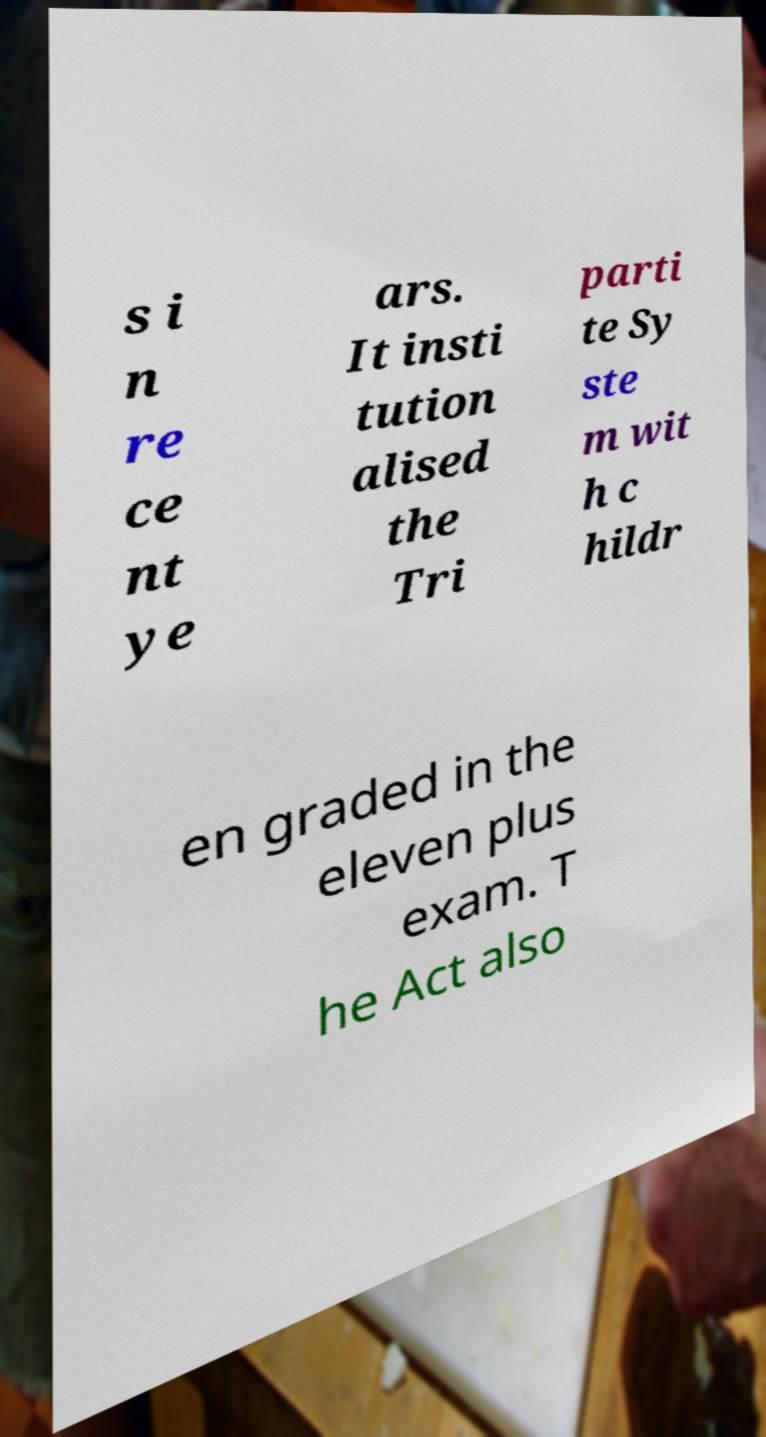Can you accurately transcribe the text from the provided image for me? s i n re ce nt ye ars. It insti tution alised the Tri parti te Sy ste m wit h c hildr en graded in the eleven plus exam. T he Act also 